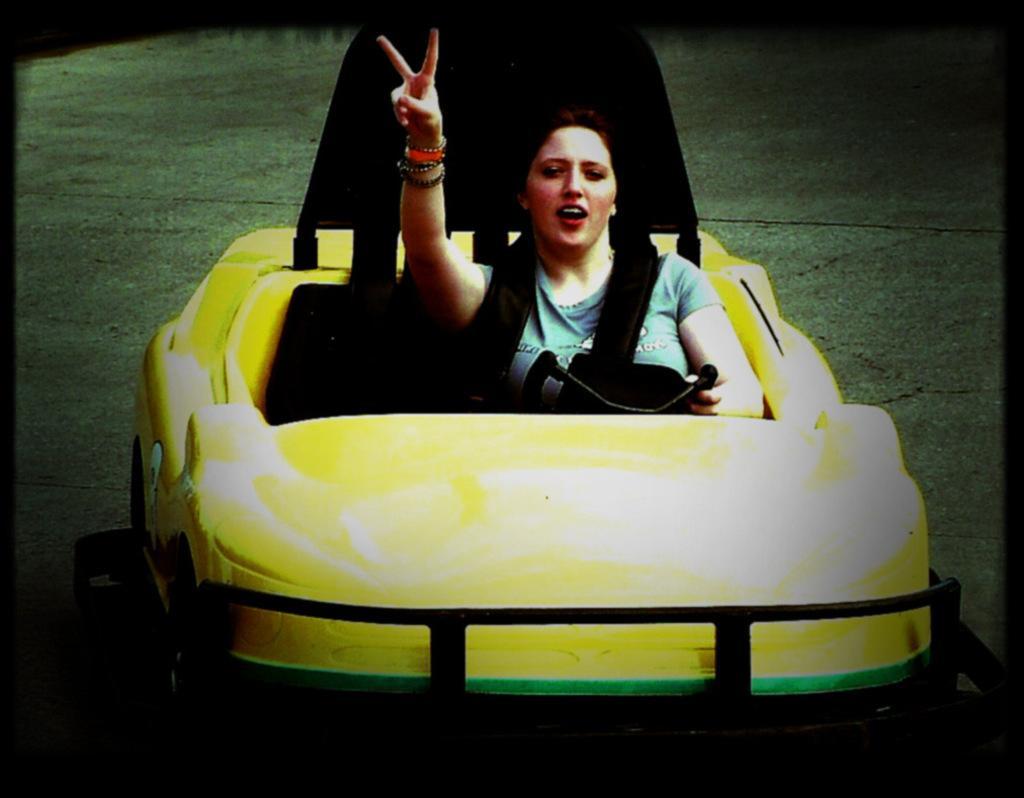Could you give a brief overview of what you see in this image? In this image I see a woman who is sitting in a car. 